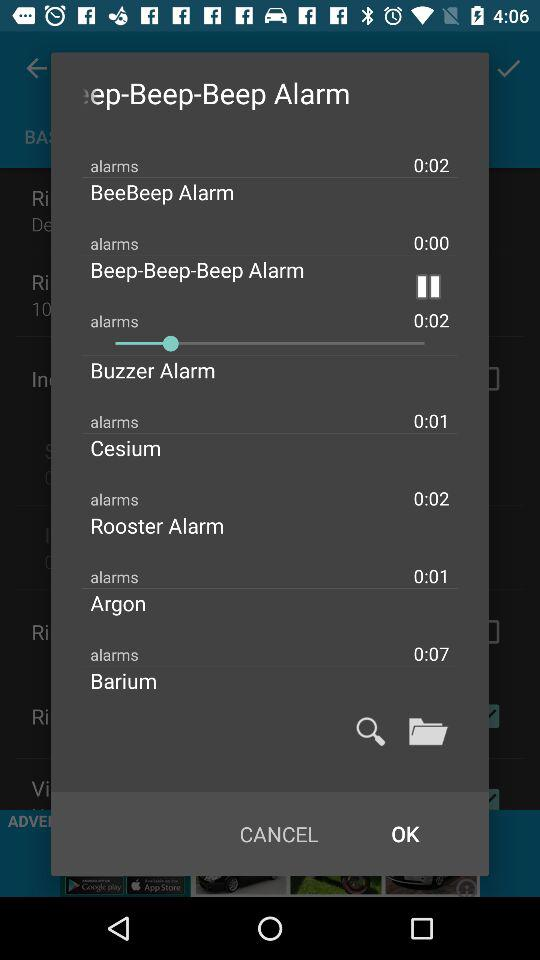What is the length of the Rooster alarm? The length is 0:01. 